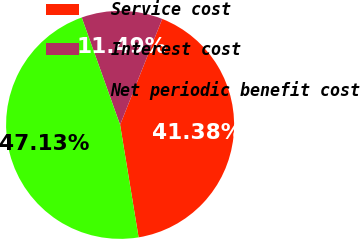<chart> <loc_0><loc_0><loc_500><loc_500><pie_chart><fcel>Service cost<fcel>Interest cost<fcel>Net periodic benefit cost<nl><fcel>41.38%<fcel>11.49%<fcel>47.13%<nl></chart> 